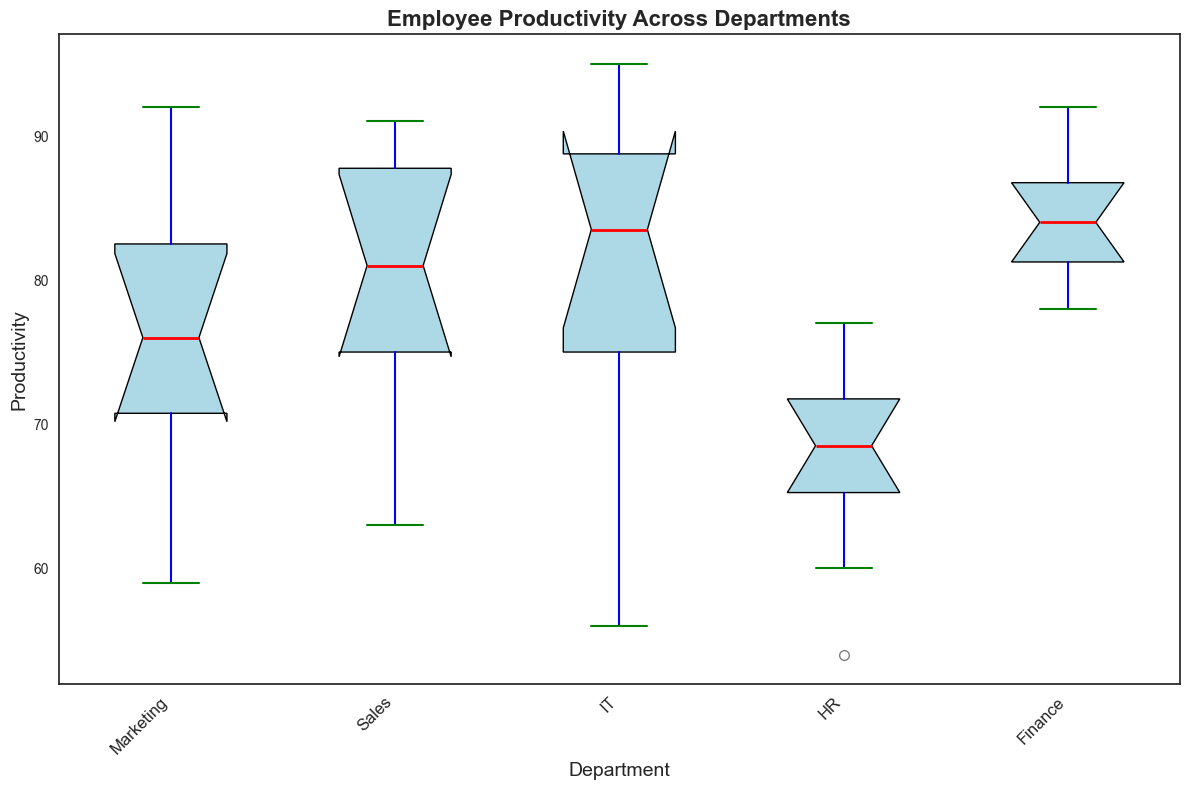What is the median productivity score for the Marketing department? Locate the boxplot corresponding to the Marketing department. The red line inside the box represents the median value.
Answer: 75 Which department has the highest median productivity? Compare the red lines inside the boxes across all departments. The department with the highest red line has the highest median productivity.
Answer: IT How does the range of productivity scores in the HR department compare to the range in the Finance department? Look at the distances between the whiskers (ends of the vertical lines) for both HR and Finance. Calculate the range for each by subtracting the smallest value from the largest value. Compare the two ranges.
Answer: Finance range is larger What are the upper and lower quartiles (25th and 75th percentile) for the Sales department? Identify the top and bottom edges of the box for the Sales department. These represent the 75th percentile (upper quartile) and 25th percentile (lower quartile) respectively.
Answer: 90 (75th), 74 (25th) How many outliers are in the HR department? Outliers are represented by points outside the whiskers of the boxplot. Count the dots outside the whiskers for the HR department.
Answer: 1 Which department has the smallest variability in productivity? Variability can be inferred from the width of the box; narrower boxes indicate less variability.
Answer: Finance Is there any department where the median productivity is lower than the 25th percentile of the Marketing department? Identify the 25th percentile value of Marketing by looking at the bottom edge of its box. Compare the median lines of other departments to see if any are lower.
Answer: Yes, HR What is the difference between the median productivity scores of the IT and Sales departments? Locate the red median line for IT and Sales. Subtract the Sales median from the IT median.
Answer: 9 Which department has the widest interquartile range (IQR)? The IQR is the distance between the top and bottom box edges. Compare this distance across all departments.
Answer: Marketing Are there any departments where no outliers are observed? Check each boxplot to see if there are any points outside the whiskers. Identify the departments with no points outside the whiskers.
Answer: IT, Finance, Sales 